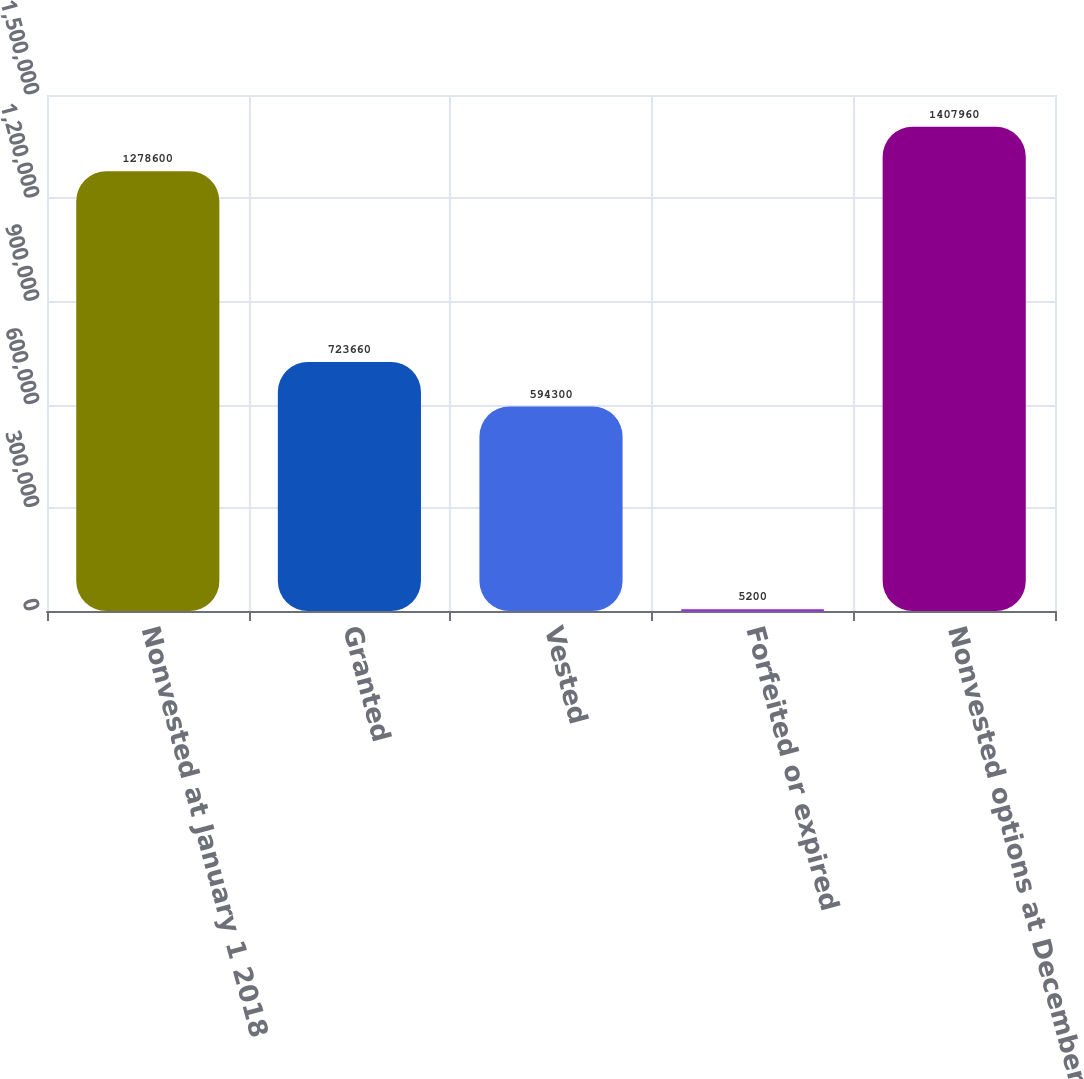<chart> <loc_0><loc_0><loc_500><loc_500><bar_chart><fcel>Nonvested at January 1 2018<fcel>Granted<fcel>Vested<fcel>Forfeited or expired<fcel>Nonvested options at December<nl><fcel>1.2786e+06<fcel>723660<fcel>594300<fcel>5200<fcel>1.40796e+06<nl></chart> 